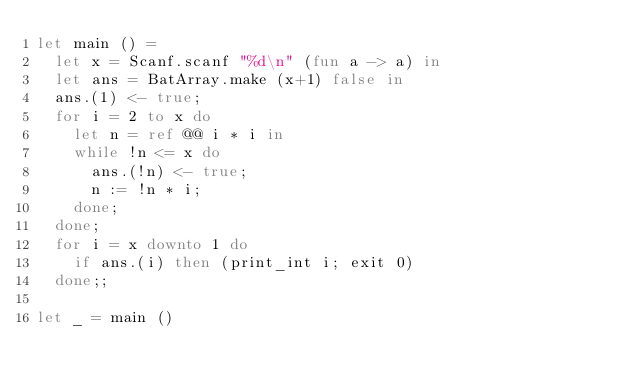<code> <loc_0><loc_0><loc_500><loc_500><_OCaml_>let main () =
  let x = Scanf.scanf "%d\n" (fun a -> a) in
  let ans = BatArray.make (x+1) false in
  ans.(1) <- true;
  for i = 2 to x do
    let n = ref @@ i * i in
    while !n <= x do
      ans.(!n) <- true;
      n := !n * i;
    done;
  done;
  for i = x downto 1 do
    if ans.(i) then (print_int i; exit 0)
  done;;

let _ = main ()
</code> 